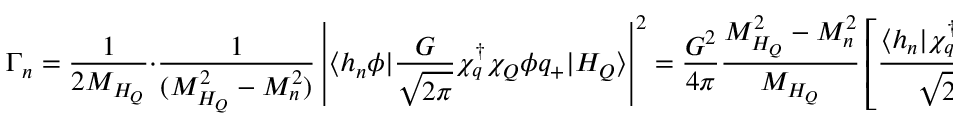Convert formula to latex. <formula><loc_0><loc_0><loc_500><loc_500>\Gamma _ { n } = \frac { 1 } { 2 M _ { H _ { Q } } } \cdot \frac { 1 } { ( M _ { H _ { Q } } ^ { 2 } - M _ { n } ^ { 2 } ) } \left | \langle h _ { n } \phi | { \frac { G } { \sqrt { 2 \pi } } \chi _ { q } ^ { \dagger } \chi _ { Q } \phi q _ { + } } | H _ { Q } \rangle \right | ^ { 2 } = \frac { G ^ { 2 } } { 4 \pi } \frac { M _ { H _ { Q } } ^ { 2 } - M _ { n } ^ { 2 } } { M _ { H _ { Q } } } \left [ \frac { \langle h _ { n } | \chi _ { q } ^ { \dagger } \chi _ { Q } | H _ { Q } \rangle } { \sqrt { 2 } M _ { H _ { Q } } } \right ] ^ { 2 }</formula> 